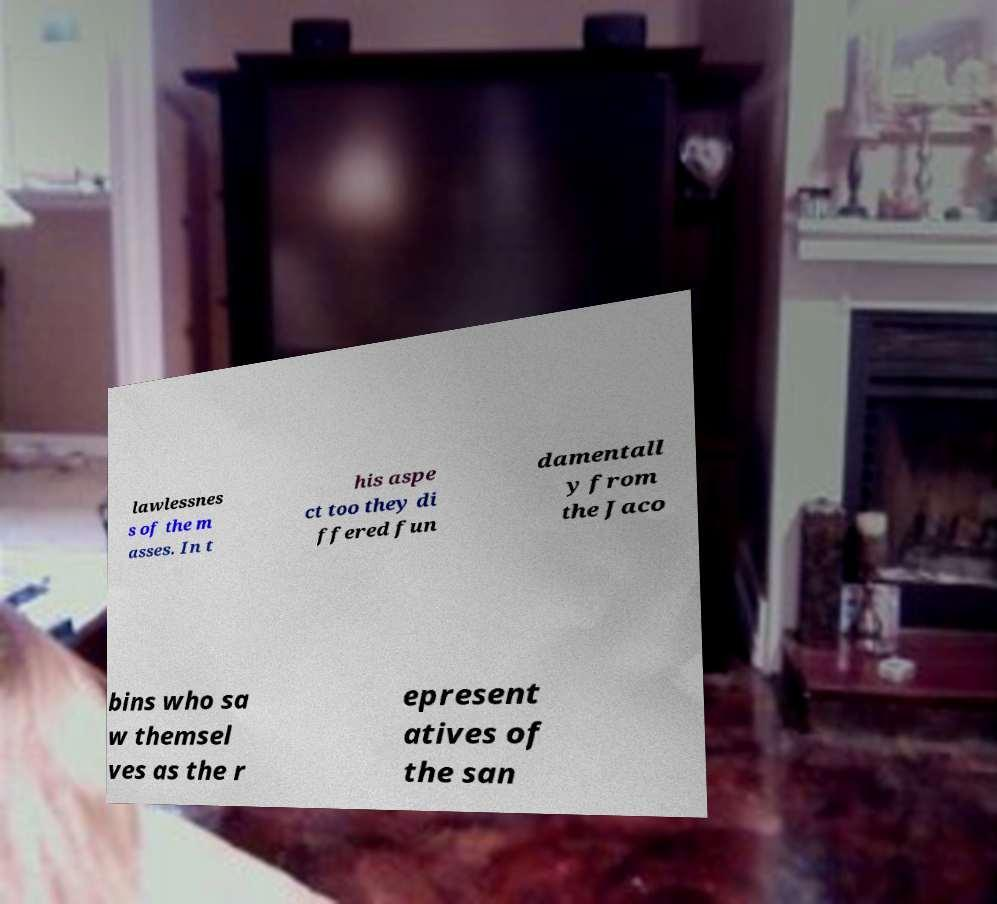Could you extract and type out the text from this image? lawlessnes s of the m asses. In t his aspe ct too they di ffered fun damentall y from the Jaco bins who sa w themsel ves as the r epresent atives of the san 